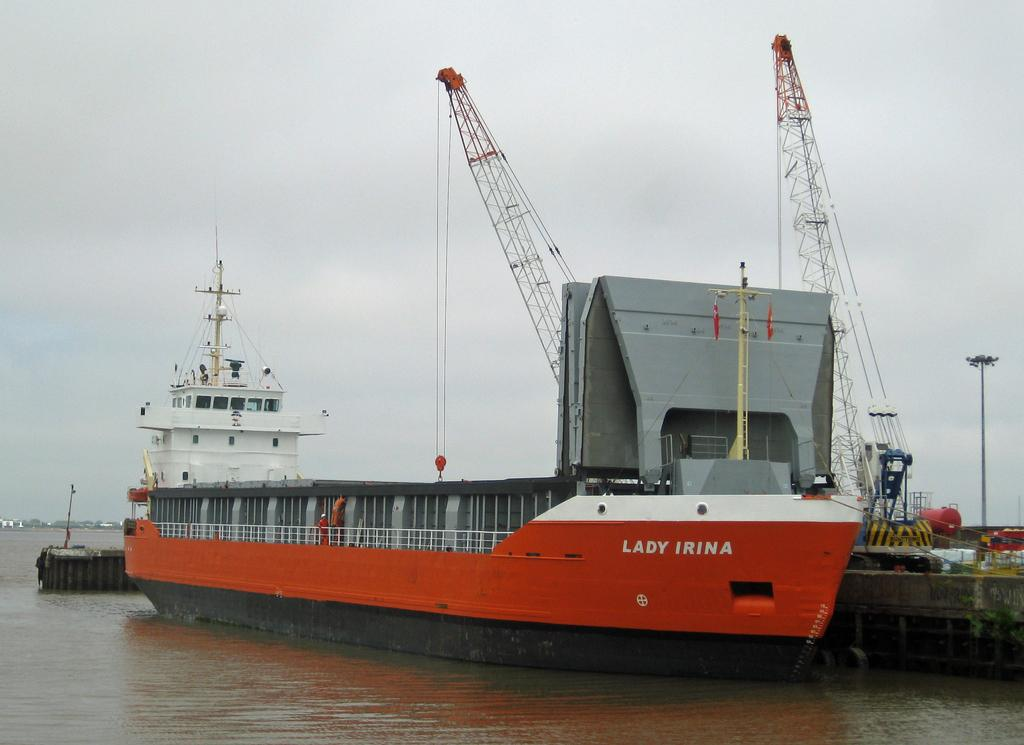<image>
Summarize the visual content of the image. A boat says "LADY IRINA" on the side. 